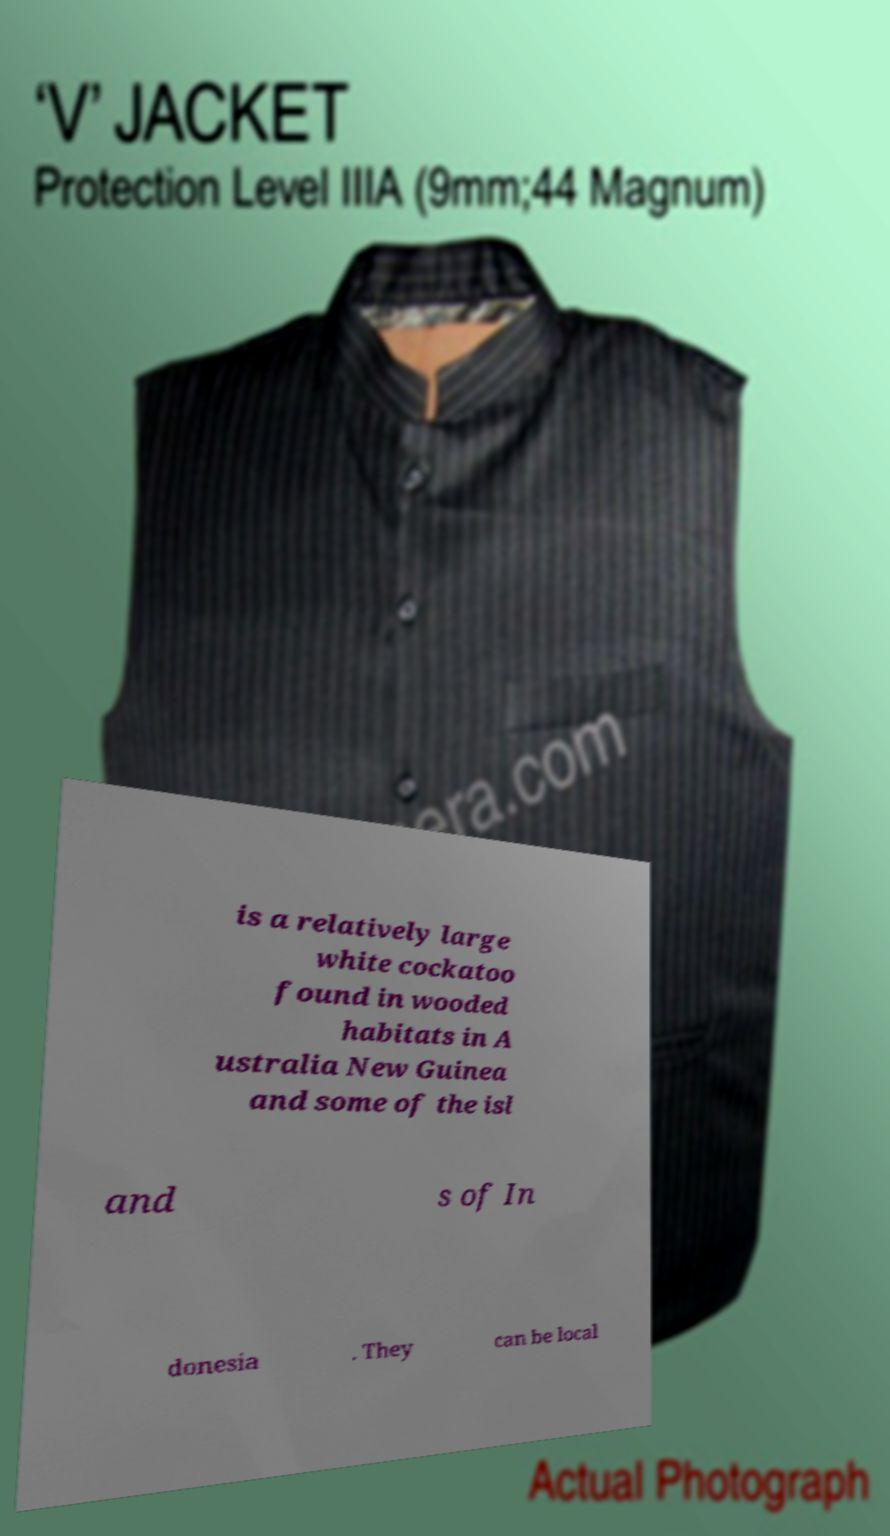Could you assist in decoding the text presented in this image and type it out clearly? is a relatively large white cockatoo found in wooded habitats in A ustralia New Guinea and some of the isl and s of In donesia . They can be local 